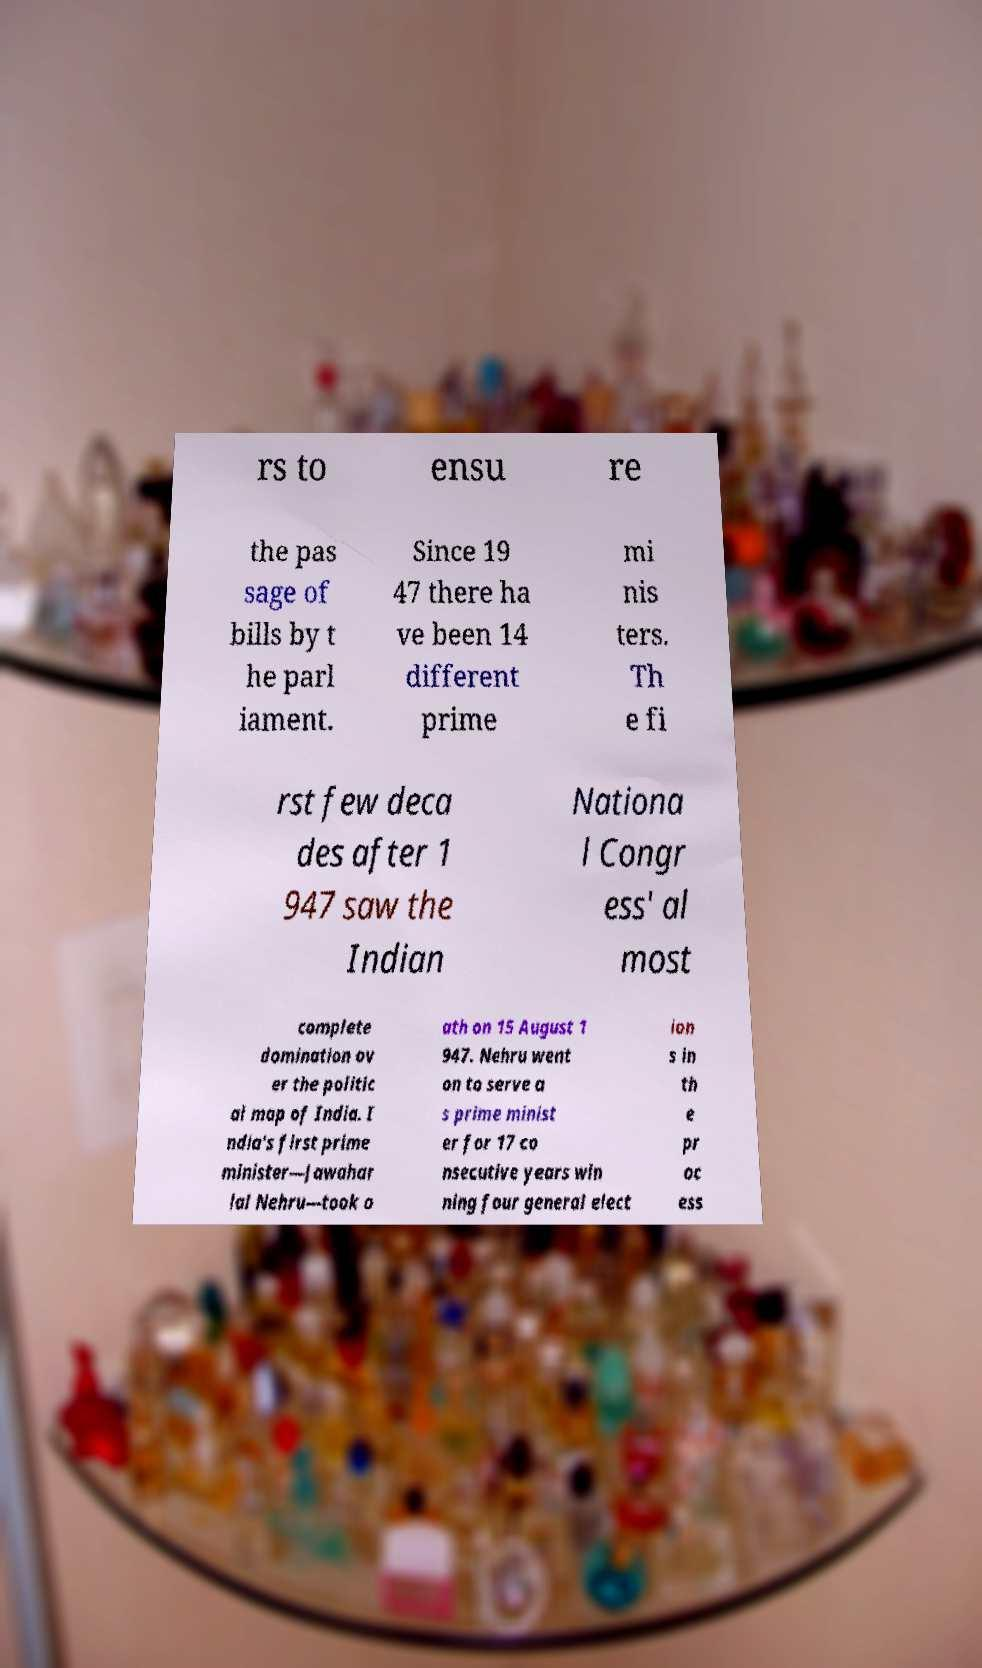What messages or text are displayed in this image? I need them in a readable, typed format. rs to ensu re the pas sage of bills by t he parl iament. Since 19 47 there ha ve been 14 different prime mi nis ters. Th e fi rst few deca des after 1 947 saw the Indian Nationa l Congr ess' al most complete domination ov er the politic al map of India. I ndia's first prime minister—Jawahar lal Nehru—took o ath on 15 August 1 947. Nehru went on to serve a s prime minist er for 17 co nsecutive years win ning four general elect ion s in th e pr oc ess 